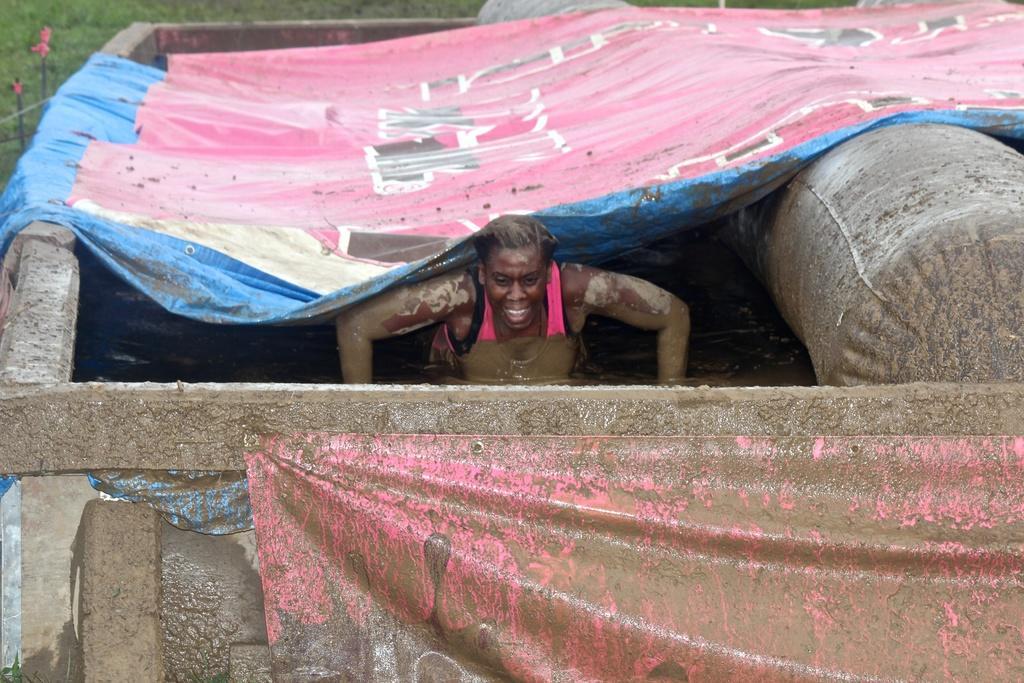Can you describe this image briefly? In this image I see a person over here who is wearing tank top and I see that the person is in the water and I see the banners and I see a thing over here. In the background I see the green grass. 